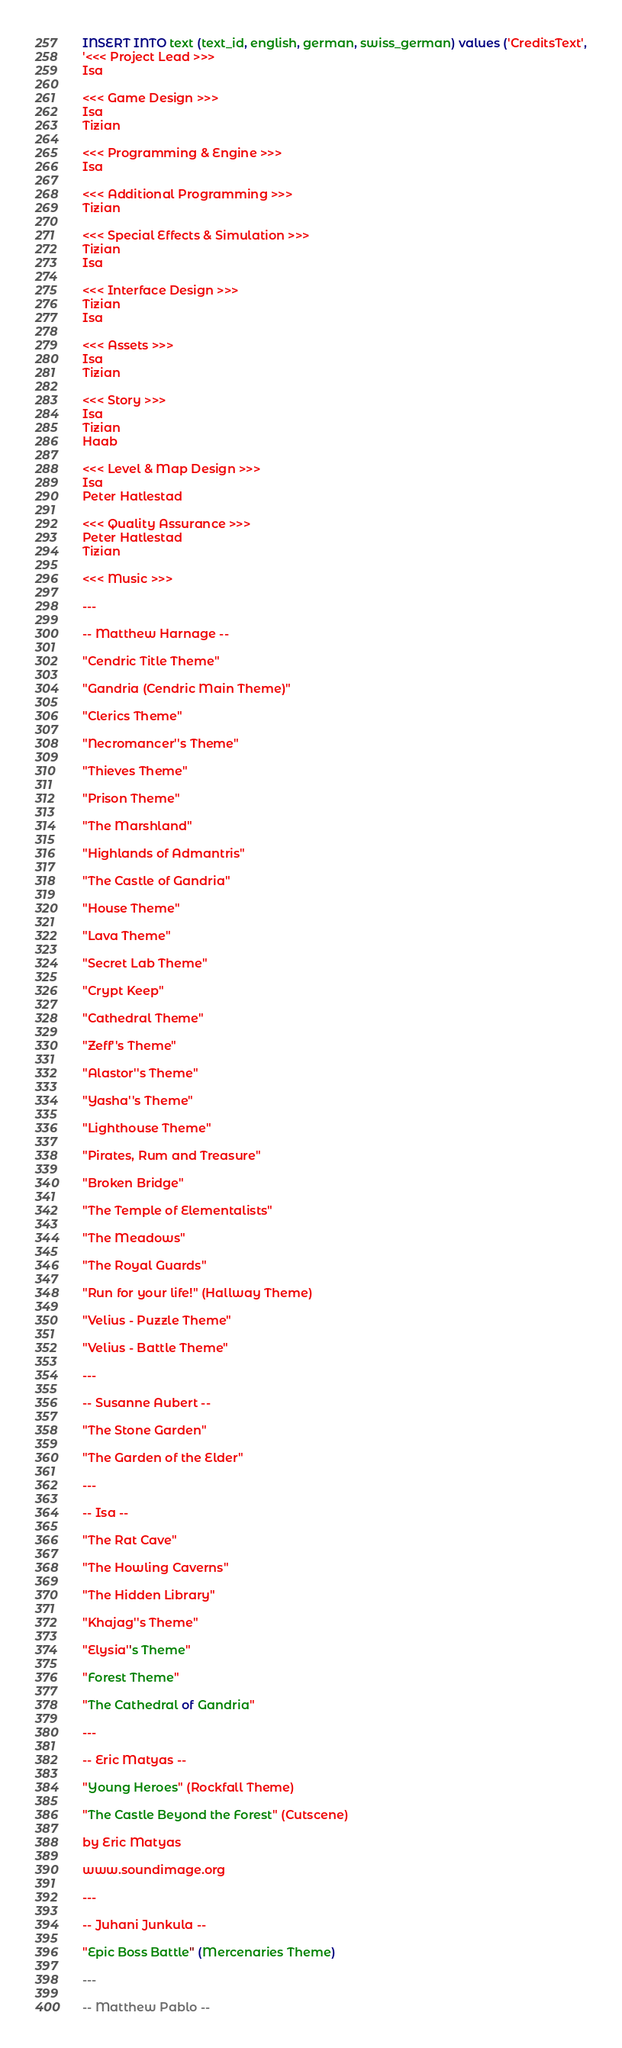<code> <loc_0><loc_0><loc_500><loc_500><_SQL_>INSERT INTO text (text_id, english, german, swiss_german) values ('CreditsText',
'<<< Project Lead >>>
Isa

<<< Game Design >>>
Isa
Tizian

<<< Programming & Engine >>>
Isa

<<< Additional Programming >>>
Tizian

<<< Special Effects & Simulation >>>
Tizian
Isa

<<< Interface Design >>>
Tizian
Isa

<<< Assets >>>
Isa
Tizian

<<< Story >>>
Isa
Tizian
Haab

<<< Level & Map Design >>>
Isa
Peter Hatlestad

<<< Quality Assurance >>>
Peter Hatlestad
Tizian

<<< Music >>>

---

-- Matthew Harnage --

"Cendric Title Theme"

"Gandria (Cendric Main Theme)"

"Clerics Theme"

"Necromancer''s Theme"

"Thieves Theme"

"Prison Theme"

"The Marshland"

"Highlands of Admantris"

"The Castle of Gandria"

"House Theme"

"Lava Theme"

"Secret Lab Theme"

"Crypt Keep"

"Cathedral Theme"

"Zeff''s Theme"

"Alastor''s Theme"

"Yasha''s Theme"

"Lighthouse Theme"

"Pirates, Rum and Treasure"

"Broken Bridge"

"The Temple of Elementalists"

"The Meadows"

"The Royal Guards"

"Run for your life!" (Hallway Theme)

"Velius - Puzzle Theme"

"Velius - Battle Theme"

---

-- Susanne Aubert --

"The Stone Garden"

"The Garden of the Elder"

---

-- Isa --

"The Rat Cave"

"The Howling Caverns"

"The Hidden Library"

"Khajag''s Theme"

"Elysia''s Theme"

"Forest Theme"

"The Cathedral of Gandria"

---

-- Eric Matyas --

"Young Heroes" (Rockfall Theme)

"The Castle Beyond the Forest" (Cutscene)

by Eric Matyas

www.soundimage.org

---

-- Juhani Junkula --

"Epic Boss Battle" (Mercenaries Theme)

---

-- Matthew Pablo --
</code> 